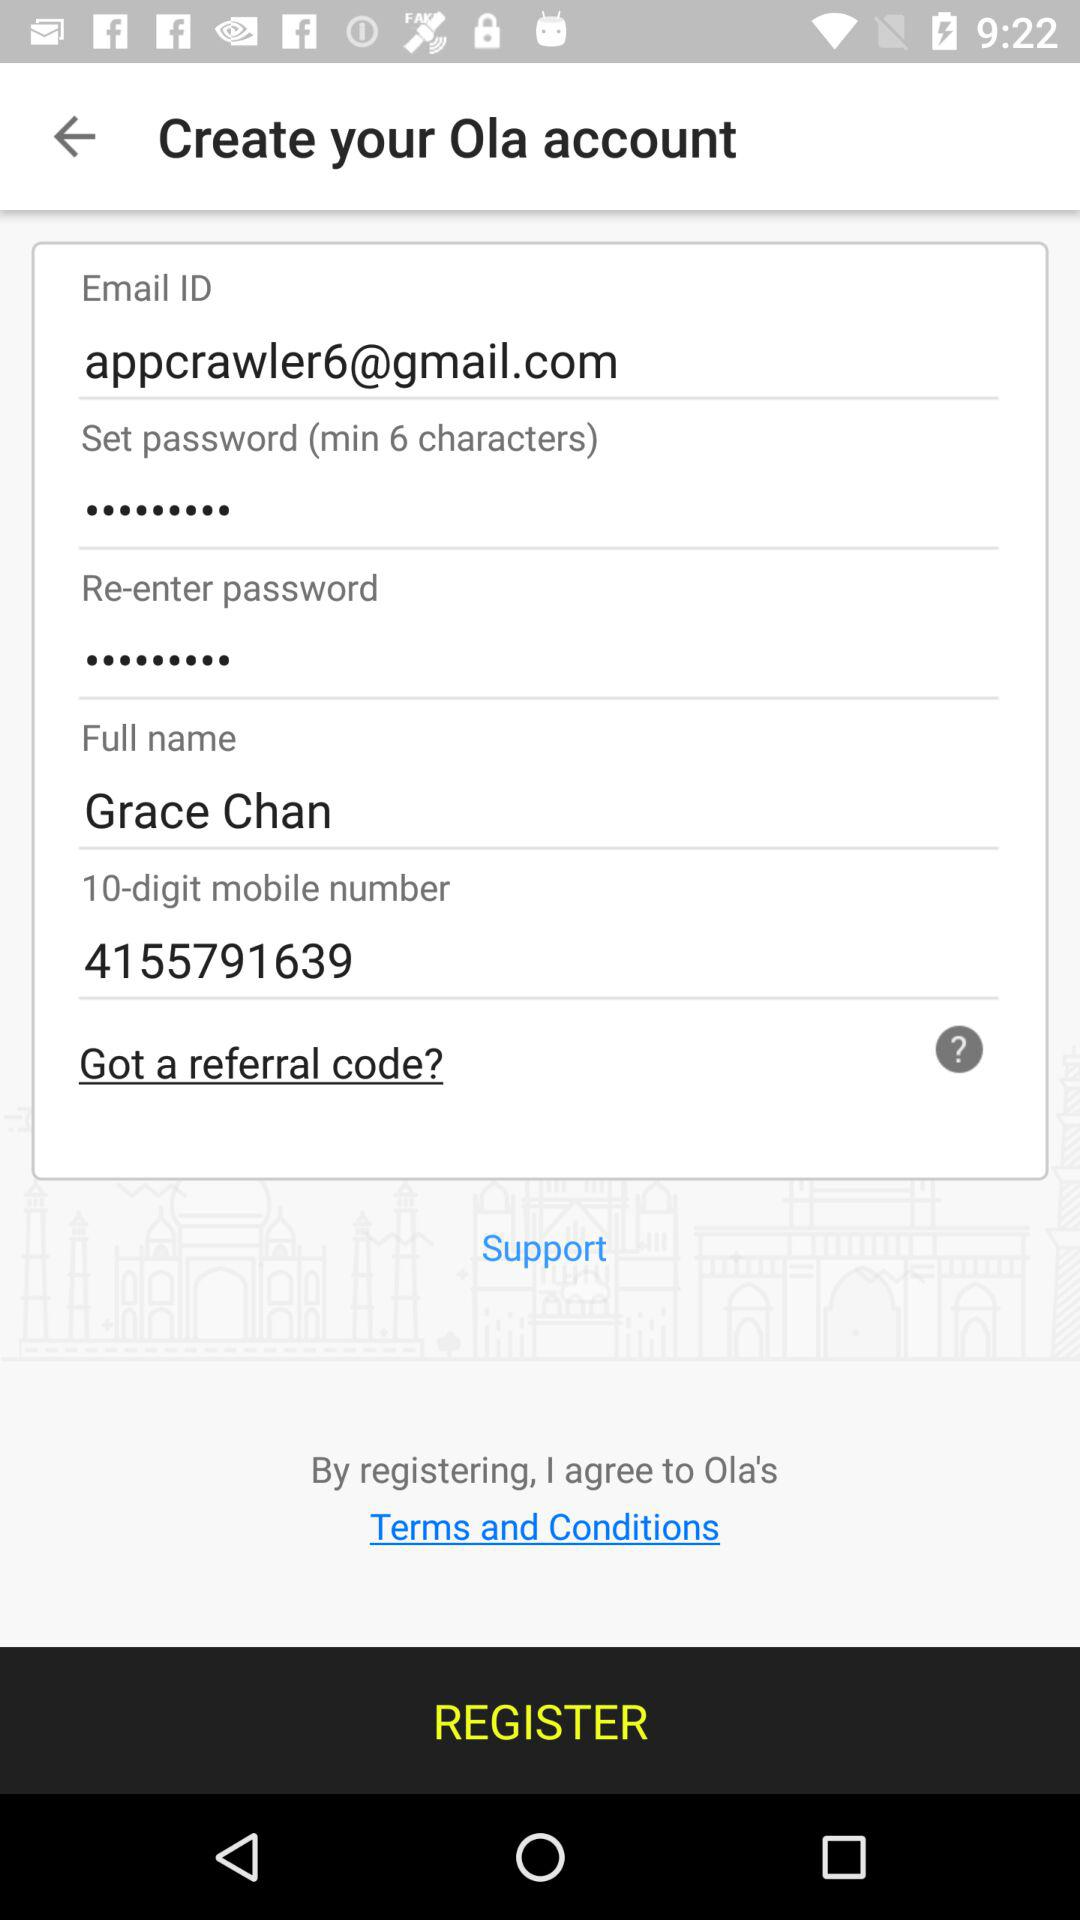What is the user name? The user name is Grace Chan. 